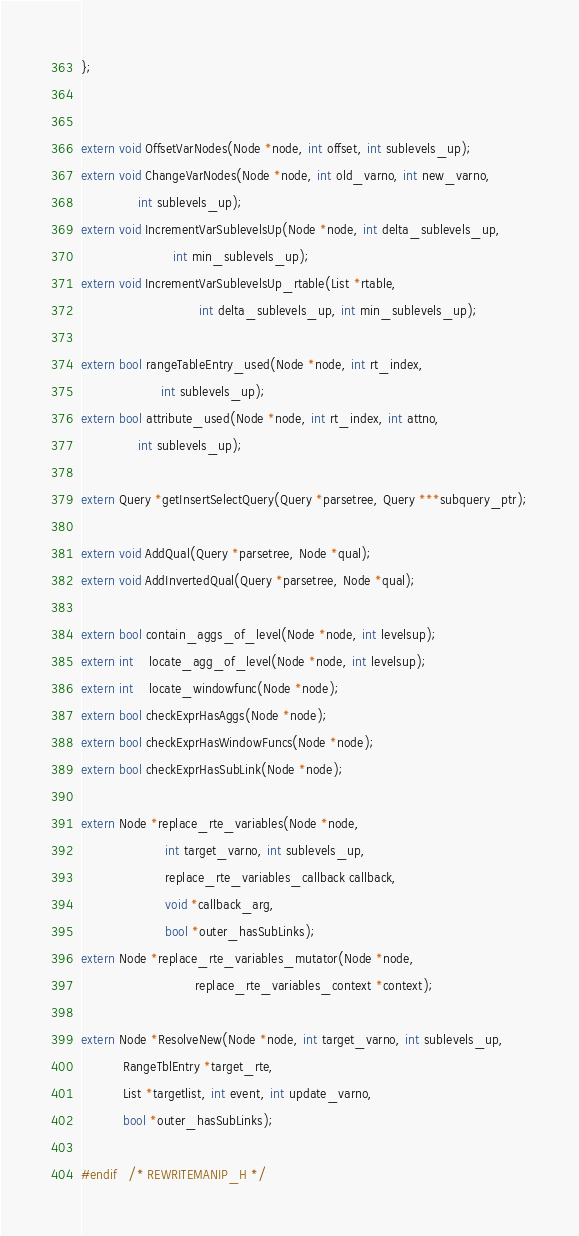Convert code to text. <code><loc_0><loc_0><loc_500><loc_500><_C_>};


extern void OffsetVarNodes(Node *node, int offset, int sublevels_up);
extern void ChangeVarNodes(Node *node, int old_varno, int new_varno,
			   int sublevels_up);
extern void IncrementVarSublevelsUp(Node *node, int delta_sublevels_up,
						int min_sublevels_up);
extern void IncrementVarSublevelsUp_rtable(List *rtable,
							   int delta_sublevels_up, int min_sublevels_up);

extern bool rangeTableEntry_used(Node *node, int rt_index,
					 int sublevels_up);
extern bool attribute_used(Node *node, int rt_index, int attno,
			   int sublevels_up);

extern Query *getInsertSelectQuery(Query *parsetree, Query ***subquery_ptr);

extern void AddQual(Query *parsetree, Node *qual);
extern void AddInvertedQual(Query *parsetree, Node *qual);

extern bool contain_aggs_of_level(Node *node, int levelsup);
extern int	locate_agg_of_level(Node *node, int levelsup);
extern int	locate_windowfunc(Node *node);
extern bool checkExprHasAggs(Node *node);
extern bool checkExprHasWindowFuncs(Node *node);
extern bool checkExprHasSubLink(Node *node);

extern Node *replace_rte_variables(Node *node,
					  int target_varno, int sublevels_up,
					  replace_rte_variables_callback callback,
					  void *callback_arg,
					  bool *outer_hasSubLinks);
extern Node *replace_rte_variables_mutator(Node *node,
							  replace_rte_variables_context *context);

extern Node *ResolveNew(Node *node, int target_varno, int sublevels_up,
		   RangeTblEntry *target_rte,
		   List *targetlist, int event, int update_varno,
		   bool *outer_hasSubLinks);

#endif   /* REWRITEMANIP_H */
</code> 